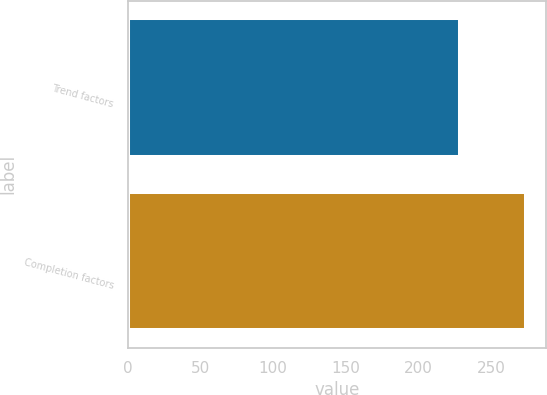Convert chart to OTSL. <chart><loc_0><loc_0><loc_500><loc_500><bar_chart><fcel>Trend factors<fcel>Completion factors<nl><fcel>229<fcel>274<nl></chart> 